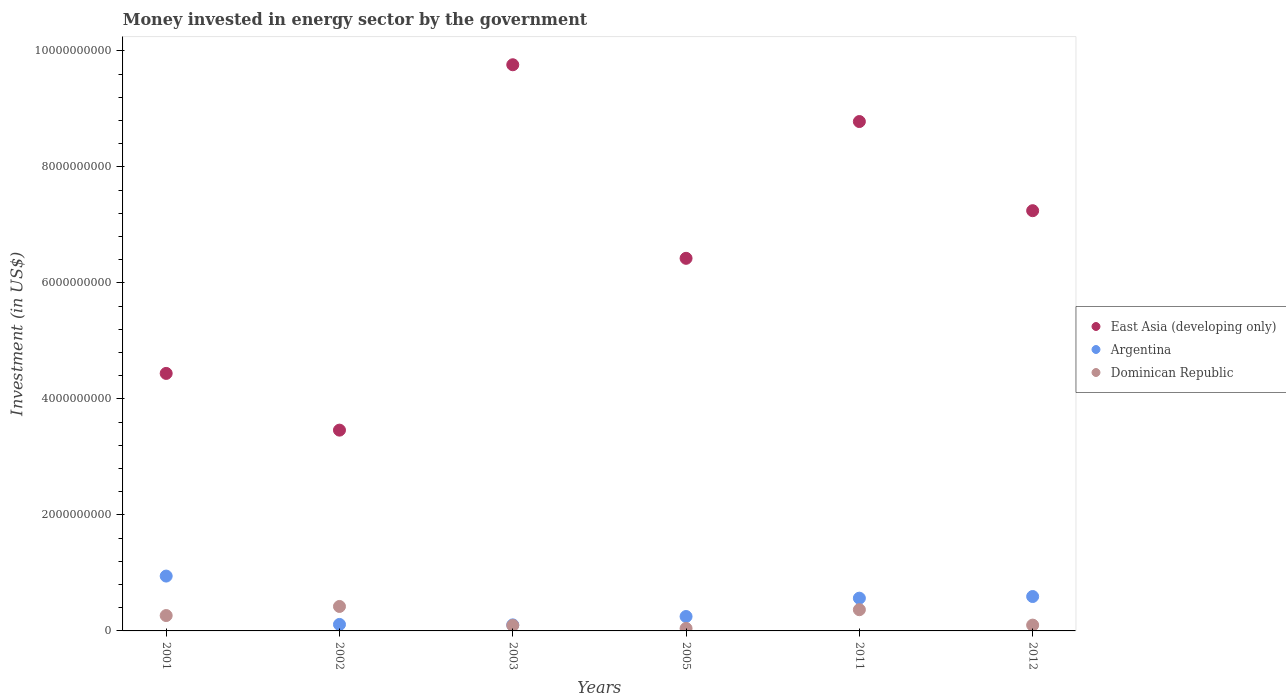How many different coloured dotlines are there?
Provide a short and direct response. 3. What is the money spent in energy sector in Dominican Republic in 2011?
Make the answer very short. 3.66e+08. Across all years, what is the maximum money spent in energy sector in Argentina?
Your response must be concise. 9.46e+08. Across all years, what is the minimum money spent in energy sector in East Asia (developing only)?
Make the answer very short. 3.46e+09. In which year was the money spent in energy sector in East Asia (developing only) maximum?
Offer a very short reply. 2003. In which year was the money spent in energy sector in Dominican Republic minimum?
Your response must be concise. 2005. What is the total money spent in energy sector in East Asia (developing only) in the graph?
Offer a terse response. 4.01e+1. What is the difference between the money spent in energy sector in Dominican Republic in 2001 and that in 2003?
Offer a terse response. 1.70e+08. What is the difference between the money spent in energy sector in East Asia (developing only) in 2011 and the money spent in energy sector in Dominican Republic in 2001?
Provide a short and direct response. 8.52e+09. What is the average money spent in energy sector in East Asia (developing only) per year?
Give a very brief answer. 6.68e+09. In the year 2002, what is the difference between the money spent in energy sector in East Asia (developing only) and money spent in energy sector in Dominican Republic?
Provide a succinct answer. 3.04e+09. What is the ratio of the money spent in energy sector in East Asia (developing only) in 2003 to that in 2005?
Provide a short and direct response. 1.52. Is the money spent in energy sector in Argentina in 2002 less than that in 2003?
Offer a very short reply. No. What is the difference between the highest and the second highest money spent in energy sector in East Asia (developing only)?
Keep it short and to the point. 9.79e+08. What is the difference between the highest and the lowest money spent in energy sector in East Asia (developing only)?
Offer a terse response. 6.30e+09. Is the sum of the money spent in energy sector in Argentina in 2001 and 2011 greater than the maximum money spent in energy sector in Dominican Republic across all years?
Your answer should be compact. Yes. Is the money spent in energy sector in Dominican Republic strictly greater than the money spent in energy sector in East Asia (developing only) over the years?
Give a very brief answer. No. Is the money spent in energy sector in East Asia (developing only) strictly less than the money spent in energy sector in Argentina over the years?
Your answer should be compact. No. What is the difference between two consecutive major ticks on the Y-axis?
Provide a short and direct response. 2.00e+09. Are the values on the major ticks of Y-axis written in scientific E-notation?
Make the answer very short. No. Does the graph contain any zero values?
Your answer should be compact. No. Where does the legend appear in the graph?
Offer a very short reply. Center right. What is the title of the graph?
Make the answer very short. Money invested in energy sector by the government. What is the label or title of the Y-axis?
Provide a short and direct response. Investment (in US$). What is the Investment (in US$) of East Asia (developing only) in 2001?
Your answer should be very brief. 4.44e+09. What is the Investment (in US$) of Argentina in 2001?
Your answer should be very brief. 9.46e+08. What is the Investment (in US$) of Dominican Republic in 2001?
Offer a very short reply. 2.65e+08. What is the Investment (in US$) in East Asia (developing only) in 2002?
Offer a very short reply. 3.46e+09. What is the Investment (in US$) of Argentina in 2002?
Provide a succinct answer. 1.12e+08. What is the Investment (in US$) of Dominican Republic in 2002?
Your answer should be very brief. 4.22e+08. What is the Investment (in US$) of East Asia (developing only) in 2003?
Offer a very short reply. 9.76e+09. What is the Investment (in US$) in Argentina in 2003?
Offer a terse response. 1.04e+08. What is the Investment (in US$) of Dominican Republic in 2003?
Ensure brevity in your answer.  9.50e+07. What is the Investment (in US$) of East Asia (developing only) in 2005?
Provide a short and direct response. 6.42e+09. What is the Investment (in US$) of Argentina in 2005?
Keep it short and to the point. 2.49e+08. What is the Investment (in US$) of Dominican Republic in 2005?
Ensure brevity in your answer.  4.25e+07. What is the Investment (in US$) of East Asia (developing only) in 2011?
Offer a very short reply. 8.78e+09. What is the Investment (in US$) in Argentina in 2011?
Your answer should be very brief. 5.65e+08. What is the Investment (in US$) in Dominican Republic in 2011?
Provide a succinct answer. 3.66e+08. What is the Investment (in US$) of East Asia (developing only) in 2012?
Provide a succinct answer. 7.24e+09. What is the Investment (in US$) of Argentina in 2012?
Provide a short and direct response. 5.93e+08. Across all years, what is the maximum Investment (in US$) in East Asia (developing only)?
Provide a short and direct response. 9.76e+09. Across all years, what is the maximum Investment (in US$) of Argentina?
Give a very brief answer. 9.46e+08. Across all years, what is the maximum Investment (in US$) of Dominican Republic?
Keep it short and to the point. 4.22e+08. Across all years, what is the minimum Investment (in US$) in East Asia (developing only)?
Provide a short and direct response. 3.46e+09. Across all years, what is the minimum Investment (in US$) of Argentina?
Provide a succinct answer. 1.04e+08. Across all years, what is the minimum Investment (in US$) of Dominican Republic?
Your answer should be compact. 4.25e+07. What is the total Investment (in US$) in East Asia (developing only) in the graph?
Ensure brevity in your answer.  4.01e+1. What is the total Investment (in US$) in Argentina in the graph?
Make the answer very short. 2.57e+09. What is the total Investment (in US$) of Dominican Republic in the graph?
Give a very brief answer. 1.29e+09. What is the difference between the Investment (in US$) in East Asia (developing only) in 2001 and that in 2002?
Your answer should be very brief. 9.78e+08. What is the difference between the Investment (in US$) of Argentina in 2001 and that in 2002?
Your response must be concise. 8.34e+08. What is the difference between the Investment (in US$) in Dominican Republic in 2001 and that in 2002?
Offer a terse response. -1.57e+08. What is the difference between the Investment (in US$) in East Asia (developing only) in 2001 and that in 2003?
Keep it short and to the point. -5.32e+09. What is the difference between the Investment (in US$) in Argentina in 2001 and that in 2003?
Keep it short and to the point. 8.41e+08. What is the difference between the Investment (in US$) of Dominican Republic in 2001 and that in 2003?
Make the answer very short. 1.70e+08. What is the difference between the Investment (in US$) in East Asia (developing only) in 2001 and that in 2005?
Your response must be concise. -1.98e+09. What is the difference between the Investment (in US$) of Argentina in 2001 and that in 2005?
Make the answer very short. 6.97e+08. What is the difference between the Investment (in US$) of Dominican Republic in 2001 and that in 2005?
Provide a short and direct response. 2.22e+08. What is the difference between the Investment (in US$) of East Asia (developing only) in 2001 and that in 2011?
Ensure brevity in your answer.  -4.34e+09. What is the difference between the Investment (in US$) of Argentina in 2001 and that in 2011?
Offer a very short reply. 3.81e+08. What is the difference between the Investment (in US$) of Dominican Republic in 2001 and that in 2011?
Your answer should be compact. -1.01e+08. What is the difference between the Investment (in US$) in East Asia (developing only) in 2001 and that in 2012?
Give a very brief answer. -2.81e+09. What is the difference between the Investment (in US$) in Argentina in 2001 and that in 2012?
Keep it short and to the point. 3.52e+08. What is the difference between the Investment (in US$) in Dominican Republic in 2001 and that in 2012?
Make the answer very short. 1.65e+08. What is the difference between the Investment (in US$) in East Asia (developing only) in 2002 and that in 2003?
Your answer should be compact. -6.30e+09. What is the difference between the Investment (in US$) of Argentina in 2002 and that in 2003?
Provide a short and direct response. 7.79e+06. What is the difference between the Investment (in US$) in Dominican Republic in 2002 and that in 2003?
Your answer should be compact. 3.27e+08. What is the difference between the Investment (in US$) of East Asia (developing only) in 2002 and that in 2005?
Offer a very short reply. -2.96e+09. What is the difference between the Investment (in US$) in Argentina in 2002 and that in 2005?
Give a very brief answer. -1.37e+08. What is the difference between the Investment (in US$) in Dominican Republic in 2002 and that in 2005?
Make the answer very short. 3.79e+08. What is the difference between the Investment (in US$) of East Asia (developing only) in 2002 and that in 2011?
Your answer should be very brief. -5.32e+09. What is the difference between the Investment (in US$) of Argentina in 2002 and that in 2011?
Your answer should be compact. -4.53e+08. What is the difference between the Investment (in US$) of Dominican Republic in 2002 and that in 2011?
Provide a short and direct response. 5.61e+07. What is the difference between the Investment (in US$) in East Asia (developing only) in 2002 and that in 2012?
Provide a succinct answer. -3.78e+09. What is the difference between the Investment (in US$) of Argentina in 2002 and that in 2012?
Ensure brevity in your answer.  -4.81e+08. What is the difference between the Investment (in US$) in Dominican Republic in 2002 and that in 2012?
Offer a very short reply. 3.22e+08. What is the difference between the Investment (in US$) in East Asia (developing only) in 2003 and that in 2005?
Your answer should be very brief. 3.34e+09. What is the difference between the Investment (in US$) in Argentina in 2003 and that in 2005?
Offer a terse response. -1.45e+08. What is the difference between the Investment (in US$) of Dominican Republic in 2003 and that in 2005?
Provide a succinct answer. 5.25e+07. What is the difference between the Investment (in US$) of East Asia (developing only) in 2003 and that in 2011?
Offer a terse response. 9.79e+08. What is the difference between the Investment (in US$) in Argentina in 2003 and that in 2011?
Provide a succinct answer. -4.61e+08. What is the difference between the Investment (in US$) of Dominican Republic in 2003 and that in 2011?
Make the answer very short. -2.71e+08. What is the difference between the Investment (in US$) in East Asia (developing only) in 2003 and that in 2012?
Provide a short and direct response. 2.52e+09. What is the difference between the Investment (in US$) in Argentina in 2003 and that in 2012?
Your answer should be very brief. -4.89e+08. What is the difference between the Investment (in US$) in Dominican Republic in 2003 and that in 2012?
Your answer should be compact. -5.00e+06. What is the difference between the Investment (in US$) in East Asia (developing only) in 2005 and that in 2011?
Give a very brief answer. -2.36e+09. What is the difference between the Investment (in US$) of Argentina in 2005 and that in 2011?
Offer a terse response. -3.16e+08. What is the difference between the Investment (in US$) in Dominican Republic in 2005 and that in 2011?
Your answer should be compact. -3.23e+08. What is the difference between the Investment (in US$) of East Asia (developing only) in 2005 and that in 2012?
Make the answer very short. -8.21e+08. What is the difference between the Investment (in US$) of Argentina in 2005 and that in 2012?
Ensure brevity in your answer.  -3.44e+08. What is the difference between the Investment (in US$) of Dominican Republic in 2005 and that in 2012?
Ensure brevity in your answer.  -5.75e+07. What is the difference between the Investment (in US$) in East Asia (developing only) in 2011 and that in 2012?
Ensure brevity in your answer.  1.54e+09. What is the difference between the Investment (in US$) of Argentina in 2011 and that in 2012?
Keep it short and to the point. -2.84e+07. What is the difference between the Investment (in US$) of Dominican Republic in 2011 and that in 2012?
Provide a short and direct response. 2.66e+08. What is the difference between the Investment (in US$) in East Asia (developing only) in 2001 and the Investment (in US$) in Argentina in 2002?
Your response must be concise. 4.33e+09. What is the difference between the Investment (in US$) in East Asia (developing only) in 2001 and the Investment (in US$) in Dominican Republic in 2002?
Ensure brevity in your answer.  4.02e+09. What is the difference between the Investment (in US$) of Argentina in 2001 and the Investment (in US$) of Dominican Republic in 2002?
Provide a short and direct response. 5.24e+08. What is the difference between the Investment (in US$) of East Asia (developing only) in 2001 and the Investment (in US$) of Argentina in 2003?
Keep it short and to the point. 4.34e+09. What is the difference between the Investment (in US$) in East Asia (developing only) in 2001 and the Investment (in US$) in Dominican Republic in 2003?
Offer a very short reply. 4.34e+09. What is the difference between the Investment (in US$) in Argentina in 2001 and the Investment (in US$) in Dominican Republic in 2003?
Ensure brevity in your answer.  8.50e+08. What is the difference between the Investment (in US$) in East Asia (developing only) in 2001 and the Investment (in US$) in Argentina in 2005?
Your answer should be very brief. 4.19e+09. What is the difference between the Investment (in US$) of East Asia (developing only) in 2001 and the Investment (in US$) of Dominican Republic in 2005?
Provide a short and direct response. 4.40e+09. What is the difference between the Investment (in US$) of Argentina in 2001 and the Investment (in US$) of Dominican Republic in 2005?
Your response must be concise. 9.03e+08. What is the difference between the Investment (in US$) of East Asia (developing only) in 2001 and the Investment (in US$) of Argentina in 2011?
Offer a very short reply. 3.87e+09. What is the difference between the Investment (in US$) in East Asia (developing only) in 2001 and the Investment (in US$) in Dominican Republic in 2011?
Offer a very short reply. 4.07e+09. What is the difference between the Investment (in US$) in Argentina in 2001 and the Investment (in US$) in Dominican Republic in 2011?
Your answer should be very brief. 5.80e+08. What is the difference between the Investment (in US$) in East Asia (developing only) in 2001 and the Investment (in US$) in Argentina in 2012?
Provide a short and direct response. 3.85e+09. What is the difference between the Investment (in US$) in East Asia (developing only) in 2001 and the Investment (in US$) in Dominican Republic in 2012?
Give a very brief answer. 4.34e+09. What is the difference between the Investment (in US$) in Argentina in 2001 and the Investment (in US$) in Dominican Republic in 2012?
Your answer should be compact. 8.46e+08. What is the difference between the Investment (in US$) of East Asia (developing only) in 2002 and the Investment (in US$) of Argentina in 2003?
Your answer should be very brief. 3.36e+09. What is the difference between the Investment (in US$) in East Asia (developing only) in 2002 and the Investment (in US$) in Dominican Republic in 2003?
Ensure brevity in your answer.  3.37e+09. What is the difference between the Investment (in US$) of Argentina in 2002 and the Investment (in US$) of Dominican Republic in 2003?
Give a very brief answer. 1.68e+07. What is the difference between the Investment (in US$) of East Asia (developing only) in 2002 and the Investment (in US$) of Argentina in 2005?
Your answer should be very brief. 3.21e+09. What is the difference between the Investment (in US$) of East Asia (developing only) in 2002 and the Investment (in US$) of Dominican Republic in 2005?
Ensure brevity in your answer.  3.42e+09. What is the difference between the Investment (in US$) in Argentina in 2002 and the Investment (in US$) in Dominican Republic in 2005?
Provide a short and direct response. 6.93e+07. What is the difference between the Investment (in US$) of East Asia (developing only) in 2002 and the Investment (in US$) of Argentina in 2011?
Offer a terse response. 2.90e+09. What is the difference between the Investment (in US$) of East Asia (developing only) in 2002 and the Investment (in US$) of Dominican Republic in 2011?
Your answer should be very brief. 3.10e+09. What is the difference between the Investment (in US$) of Argentina in 2002 and the Investment (in US$) of Dominican Republic in 2011?
Make the answer very short. -2.54e+08. What is the difference between the Investment (in US$) in East Asia (developing only) in 2002 and the Investment (in US$) in Argentina in 2012?
Make the answer very short. 2.87e+09. What is the difference between the Investment (in US$) in East Asia (developing only) in 2002 and the Investment (in US$) in Dominican Republic in 2012?
Your answer should be compact. 3.36e+09. What is the difference between the Investment (in US$) of Argentina in 2002 and the Investment (in US$) of Dominican Republic in 2012?
Offer a very short reply. 1.18e+07. What is the difference between the Investment (in US$) in East Asia (developing only) in 2003 and the Investment (in US$) in Argentina in 2005?
Offer a terse response. 9.51e+09. What is the difference between the Investment (in US$) in East Asia (developing only) in 2003 and the Investment (in US$) in Dominican Republic in 2005?
Offer a very short reply. 9.72e+09. What is the difference between the Investment (in US$) in Argentina in 2003 and the Investment (in US$) in Dominican Republic in 2005?
Provide a short and direct response. 6.15e+07. What is the difference between the Investment (in US$) of East Asia (developing only) in 2003 and the Investment (in US$) of Argentina in 2011?
Your answer should be very brief. 9.20e+09. What is the difference between the Investment (in US$) in East Asia (developing only) in 2003 and the Investment (in US$) in Dominican Republic in 2011?
Provide a succinct answer. 9.39e+09. What is the difference between the Investment (in US$) of Argentina in 2003 and the Investment (in US$) of Dominican Republic in 2011?
Give a very brief answer. -2.62e+08. What is the difference between the Investment (in US$) of East Asia (developing only) in 2003 and the Investment (in US$) of Argentina in 2012?
Your response must be concise. 9.17e+09. What is the difference between the Investment (in US$) in East Asia (developing only) in 2003 and the Investment (in US$) in Dominican Republic in 2012?
Offer a very short reply. 9.66e+09. What is the difference between the Investment (in US$) in Argentina in 2003 and the Investment (in US$) in Dominican Republic in 2012?
Provide a succinct answer. 4.04e+06. What is the difference between the Investment (in US$) of East Asia (developing only) in 2005 and the Investment (in US$) of Argentina in 2011?
Your answer should be very brief. 5.86e+09. What is the difference between the Investment (in US$) of East Asia (developing only) in 2005 and the Investment (in US$) of Dominican Republic in 2011?
Offer a terse response. 6.06e+09. What is the difference between the Investment (in US$) in Argentina in 2005 and the Investment (in US$) in Dominican Republic in 2011?
Provide a short and direct response. -1.17e+08. What is the difference between the Investment (in US$) in East Asia (developing only) in 2005 and the Investment (in US$) in Argentina in 2012?
Your answer should be very brief. 5.83e+09. What is the difference between the Investment (in US$) in East Asia (developing only) in 2005 and the Investment (in US$) in Dominican Republic in 2012?
Provide a succinct answer. 6.32e+09. What is the difference between the Investment (in US$) of Argentina in 2005 and the Investment (in US$) of Dominican Republic in 2012?
Your answer should be compact. 1.49e+08. What is the difference between the Investment (in US$) in East Asia (developing only) in 2011 and the Investment (in US$) in Argentina in 2012?
Keep it short and to the point. 8.19e+09. What is the difference between the Investment (in US$) of East Asia (developing only) in 2011 and the Investment (in US$) of Dominican Republic in 2012?
Ensure brevity in your answer.  8.68e+09. What is the difference between the Investment (in US$) of Argentina in 2011 and the Investment (in US$) of Dominican Republic in 2012?
Make the answer very short. 4.65e+08. What is the average Investment (in US$) of East Asia (developing only) per year?
Ensure brevity in your answer.  6.68e+09. What is the average Investment (in US$) of Argentina per year?
Provide a short and direct response. 4.28e+08. What is the average Investment (in US$) of Dominican Republic per year?
Provide a succinct answer. 2.15e+08. In the year 2001, what is the difference between the Investment (in US$) of East Asia (developing only) and Investment (in US$) of Argentina?
Your response must be concise. 3.49e+09. In the year 2001, what is the difference between the Investment (in US$) in East Asia (developing only) and Investment (in US$) in Dominican Republic?
Provide a succinct answer. 4.17e+09. In the year 2001, what is the difference between the Investment (in US$) of Argentina and Investment (in US$) of Dominican Republic?
Your answer should be compact. 6.80e+08. In the year 2002, what is the difference between the Investment (in US$) of East Asia (developing only) and Investment (in US$) of Argentina?
Provide a succinct answer. 3.35e+09. In the year 2002, what is the difference between the Investment (in US$) of East Asia (developing only) and Investment (in US$) of Dominican Republic?
Make the answer very short. 3.04e+09. In the year 2002, what is the difference between the Investment (in US$) in Argentina and Investment (in US$) in Dominican Republic?
Your answer should be very brief. -3.10e+08. In the year 2003, what is the difference between the Investment (in US$) in East Asia (developing only) and Investment (in US$) in Argentina?
Your answer should be very brief. 9.66e+09. In the year 2003, what is the difference between the Investment (in US$) in East Asia (developing only) and Investment (in US$) in Dominican Republic?
Your answer should be very brief. 9.67e+09. In the year 2003, what is the difference between the Investment (in US$) in Argentina and Investment (in US$) in Dominican Republic?
Offer a terse response. 9.04e+06. In the year 2005, what is the difference between the Investment (in US$) in East Asia (developing only) and Investment (in US$) in Argentina?
Your answer should be compact. 6.17e+09. In the year 2005, what is the difference between the Investment (in US$) in East Asia (developing only) and Investment (in US$) in Dominican Republic?
Offer a terse response. 6.38e+09. In the year 2005, what is the difference between the Investment (in US$) in Argentina and Investment (in US$) in Dominican Republic?
Keep it short and to the point. 2.06e+08. In the year 2011, what is the difference between the Investment (in US$) of East Asia (developing only) and Investment (in US$) of Argentina?
Ensure brevity in your answer.  8.22e+09. In the year 2011, what is the difference between the Investment (in US$) of East Asia (developing only) and Investment (in US$) of Dominican Republic?
Make the answer very short. 8.42e+09. In the year 2011, what is the difference between the Investment (in US$) in Argentina and Investment (in US$) in Dominican Republic?
Give a very brief answer. 1.99e+08. In the year 2012, what is the difference between the Investment (in US$) in East Asia (developing only) and Investment (in US$) in Argentina?
Provide a succinct answer. 6.65e+09. In the year 2012, what is the difference between the Investment (in US$) in East Asia (developing only) and Investment (in US$) in Dominican Republic?
Your answer should be compact. 7.14e+09. In the year 2012, what is the difference between the Investment (in US$) of Argentina and Investment (in US$) of Dominican Republic?
Your response must be concise. 4.93e+08. What is the ratio of the Investment (in US$) in East Asia (developing only) in 2001 to that in 2002?
Your answer should be very brief. 1.28. What is the ratio of the Investment (in US$) of Argentina in 2001 to that in 2002?
Keep it short and to the point. 8.45. What is the ratio of the Investment (in US$) of Dominican Republic in 2001 to that in 2002?
Make the answer very short. 0.63. What is the ratio of the Investment (in US$) in East Asia (developing only) in 2001 to that in 2003?
Provide a succinct answer. 0.45. What is the ratio of the Investment (in US$) in Argentina in 2001 to that in 2003?
Offer a very short reply. 9.09. What is the ratio of the Investment (in US$) in Dominican Republic in 2001 to that in 2003?
Offer a terse response. 2.79. What is the ratio of the Investment (in US$) of East Asia (developing only) in 2001 to that in 2005?
Offer a terse response. 0.69. What is the ratio of the Investment (in US$) in Argentina in 2001 to that in 2005?
Give a very brief answer. 3.8. What is the ratio of the Investment (in US$) of Dominican Republic in 2001 to that in 2005?
Your answer should be compact. 6.24. What is the ratio of the Investment (in US$) in East Asia (developing only) in 2001 to that in 2011?
Your answer should be compact. 0.51. What is the ratio of the Investment (in US$) in Argentina in 2001 to that in 2011?
Offer a terse response. 1.67. What is the ratio of the Investment (in US$) in Dominican Republic in 2001 to that in 2011?
Give a very brief answer. 0.72. What is the ratio of the Investment (in US$) in East Asia (developing only) in 2001 to that in 2012?
Ensure brevity in your answer.  0.61. What is the ratio of the Investment (in US$) in Argentina in 2001 to that in 2012?
Your answer should be very brief. 1.59. What is the ratio of the Investment (in US$) in Dominican Republic in 2001 to that in 2012?
Provide a succinct answer. 2.65. What is the ratio of the Investment (in US$) of East Asia (developing only) in 2002 to that in 2003?
Offer a very short reply. 0.35. What is the ratio of the Investment (in US$) of Argentina in 2002 to that in 2003?
Your answer should be compact. 1.07. What is the ratio of the Investment (in US$) of Dominican Republic in 2002 to that in 2003?
Provide a succinct answer. 4.44. What is the ratio of the Investment (in US$) of East Asia (developing only) in 2002 to that in 2005?
Give a very brief answer. 0.54. What is the ratio of the Investment (in US$) of Argentina in 2002 to that in 2005?
Keep it short and to the point. 0.45. What is the ratio of the Investment (in US$) of Dominican Republic in 2002 to that in 2005?
Provide a short and direct response. 9.92. What is the ratio of the Investment (in US$) of East Asia (developing only) in 2002 to that in 2011?
Ensure brevity in your answer.  0.39. What is the ratio of the Investment (in US$) of Argentina in 2002 to that in 2011?
Your answer should be compact. 0.2. What is the ratio of the Investment (in US$) in Dominican Republic in 2002 to that in 2011?
Offer a very short reply. 1.15. What is the ratio of the Investment (in US$) in East Asia (developing only) in 2002 to that in 2012?
Give a very brief answer. 0.48. What is the ratio of the Investment (in US$) of Argentina in 2002 to that in 2012?
Offer a terse response. 0.19. What is the ratio of the Investment (in US$) in Dominican Republic in 2002 to that in 2012?
Ensure brevity in your answer.  4.22. What is the ratio of the Investment (in US$) in East Asia (developing only) in 2003 to that in 2005?
Provide a succinct answer. 1.52. What is the ratio of the Investment (in US$) in Argentina in 2003 to that in 2005?
Keep it short and to the point. 0.42. What is the ratio of the Investment (in US$) of Dominican Republic in 2003 to that in 2005?
Make the answer very short. 2.24. What is the ratio of the Investment (in US$) of East Asia (developing only) in 2003 to that in 2011?
Your response must be concise. 1.11. What is the ratio of the Investment (in US$) of Argentina in 2003 to that in 2011?
Offer a terse response. 0.18. What is the ratio of the Investment (in US$) in Dominican Republic in 2003 to that in 2011?
Your answer should be very brief. 0.26. What is the ratio of the Investment (in US$) in East Asia (developing only) in 2003 to that in 2012?
Your response must be concise. 1.35. What is the ratio of the Investment (in US$) of Argentina in 2003 to that in 2012?
Make the answer very short. 0.18. What is the ratio of the Investment (in US$) in Dominican Republic in 2003 to that in 2012?
Provide a succinct answer. 0.95. What is the ratio of the Investment (in US$) in East Asia (developing only) in 2005 to that in 2011?
Make the answer very short. 0.73. What is the ratio of the Investment (in US$) of Argentina in 2005 to that in 2011?
Ensure brevity in your answer.  0.44. What is the ratio of the Investment (in US$) of Dominican Republic in 2005 to that in 2011?
Make the answer very short. 0.12. What is the ratio of the Investment (in US$) of East Asia (developing only) in 2005 to that in 2012?
Give a very brief answer. 0.89. What is the ratio of the Investment (in US$) of Argentina in 2005 to that in 2012?
Your response must be concise. 0.42. What is the ratio of the Investment (in US$) in Dominican Republic in 2005 to that in 2012?
Provide a short and direct response. 0.42. What is the ratio of the Investment (in US$) of East Asia (developing only) in 2011 to that in 2012?
Give a very brief answer. 1.21. What is the ratio of the Investment (in US$) of Argentina in 2011 to that in 2012?
Your answer should be compact. 0.95. What is the ratio of the Investment (in US$) of Dominican Republic in 2011 to that in 2012?
Offer a very short reply. 3.66. What is the difference between the highest and the second highest Investment (in US$) of East Asia (developing only)?
Offer a very short reply. 9.79e+08. What is the difference between the highest and the second highest Investment (in US$) in Argentina?
Your response must be concise. 3.52e+08. What is the difference between the highest and the second highest Investment (in US$) in Dominican Republic?
Your response must be concise. 5.61e+07. What is the difference between the highest and the lowest Investment (in US$) in East Asia (developing only)?
Your response must be concise. 6.30e+09. What is the difference between the highest and the lowest Investment (in US$) in Argentina?
Make the answer very short. 8.41e+08. What is the difference between the highest and the lowest Investment (in US$) of Dominican Republic?
Provide a short and direct response. 3.79e+08. 